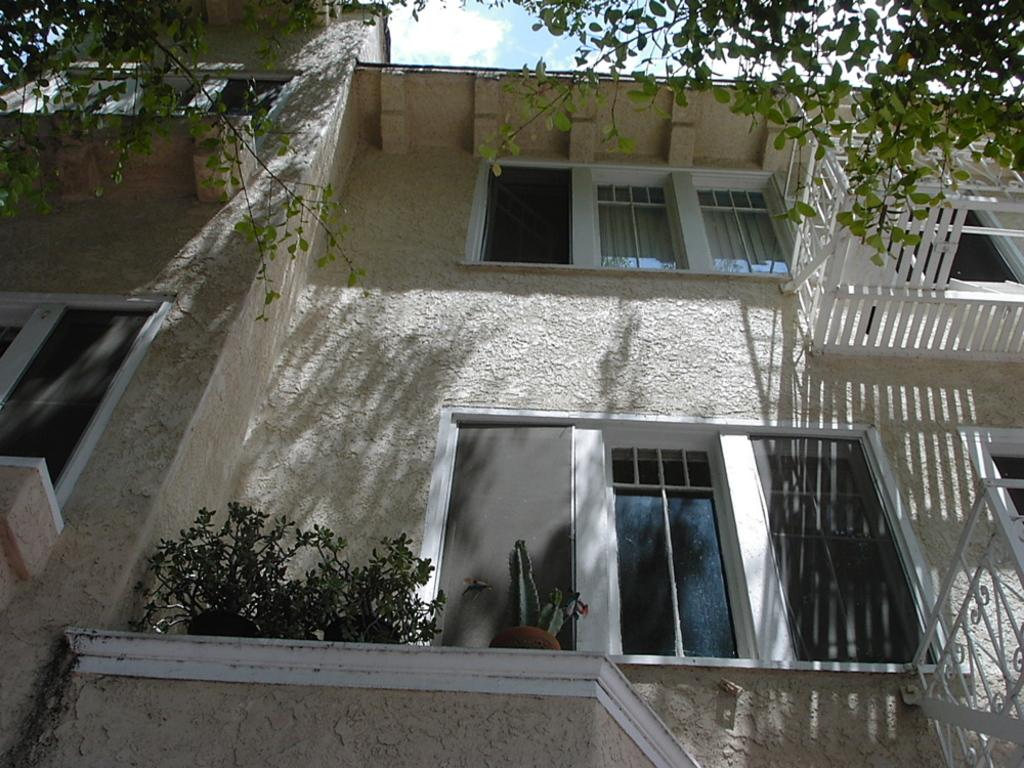What type of structure is visible in the image? There is a building in the image. What natural elements can be seen in the image? There are trees and plants in the image. What type of material is used for the rods in the image? Metal rods are present in the image. What is visible in the sky in the image? Clouds are visible at the top of the image. Can you see a guitar being played in the image? There is no guitar or anyone playing a guitar in the image. 